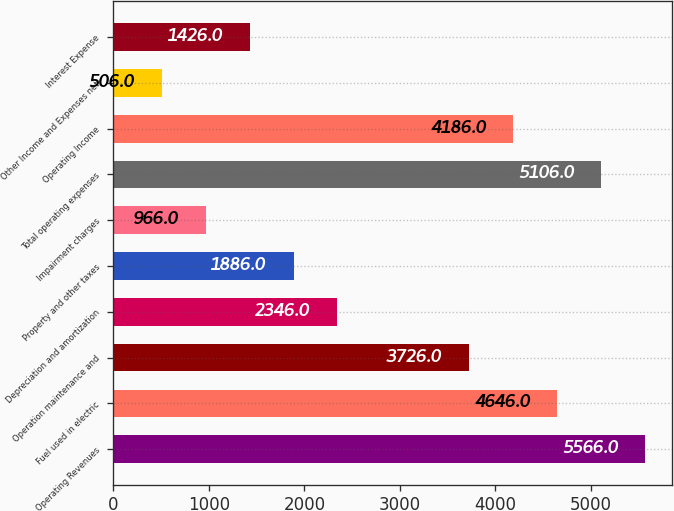Convert chart to OTSL. <chart><loc_0><loc_0><loc_500><loc_500><bar_chart><fcel>Operating Revenues<fcel>Fuel used in electric<fcel>Operation maintenance and<fcel>Depreciation and amortization<fcel>Property and other taxes<fcel>Impairment charges<fcel>Total operating expenses<fcel>Operating Income<fcel>Other Income and Expenses net<fcel>Interest Expense<nl><fcel>5566<fcel>4646<fcel>3726<fcel>2346<fcel>1886<fcel>966<fcel>5106<fcel>4186<fcel>506<fcel>1426<nl></chart> 